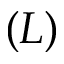Convert formula to latex. <formula><loc_0><loc_0><loc_500><loc_500>( L )</formula> 